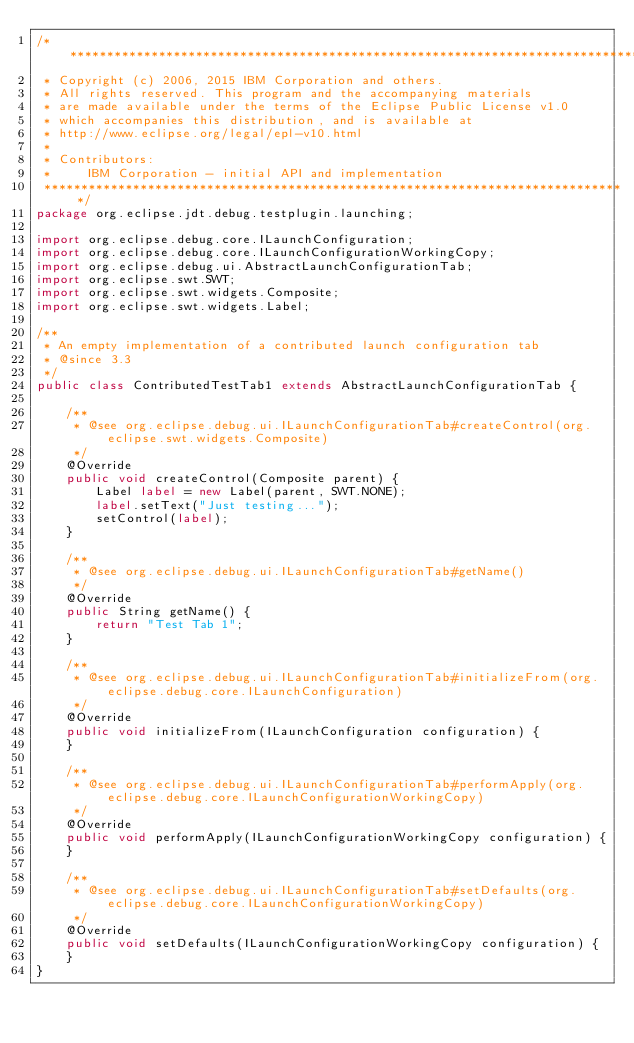<code> <loc_0><loc_0><loc_500><loc_500><_Java_>/*******************************************************************************
 * Copyright (c) 2006, 2015 IBM Corporation and others.
 * All rights reserved. This program and the accompanying materials
 * are made available under the terms of the Eclipse Public License v1.0
 * which accompanies this distribution, and is available at
 * http://www.eclipse.org/legal/epl-v10.html
 * 
 * Contributors:
 *     IBM Corporation - initial API and implementation
 *******************************************************************************/
package org.eclipse.jdt.debug.testplugin.launching;

import org.eclipse.debug.core.ILaunchConfiguration;
import org.eclipse.debug.core.ILaunchConfigurationWorkingCopy;
import org.eclipse.debug.ui.AbstractLaunchConfigurationTab;
import org.eclipse.swt.SWT;
import org.eclipse.swt.widgets.Composite;
import org.eclipse.swt.widgets.Label;

/**
 * An empty implementation of a contributed launch configuration tab
 * @since 3.3
 */
public class ContributedTestTab1 extends AbstractLaunchConfigurationTab {

    /**
	 * @see org.eclipse.debug.ui.ILaunchConfigurationTab#createControl(org.eclipse.swt.widgets.Composite)
	 */
    @Override
    public void createControl(Composite parent) {
        Label label = new Label(parent, SWT.NONE);
        label.setText("Just testing...");
        setControl(label);
    }

    /**
	 * @see org.eclipse.debug.ui.ILaunchConfigurationTab#getName()
	 */
    @Override
    public String getName() {
        return "Test Tab 1";
    }

    /**
	 * @see org.eclipse.debug.ui.ILaunchConfigurationTab#initializeFrom(org.eclipse.debug.core.ILaunchConfiguration)
	 */
    @Override
    public void initializeFrom(ILaunchConfiguration configuration) {
    }

    /**
	 * @see org.eclipse.debug.ui.ILaunchConfigurationTab#performApply(org.eclipse.debug.core.ILaunchConfigurationWorkingCopy)
	 */
    @Override
    public void performApply(ILaunchConfigurationWorkingCopy configuration) {
    }

    /**
	 * @see org.eclipse.debug.ui.ILaunchConfigurationTab#setDefaults(org.eclipse.debug.core.ILaunchConfigurationWorkingCopy)
	 */
    @Override
    public void setDefaults(ILaunchConfigurationWorkingCopy configuration) {
    }
}
</code> 